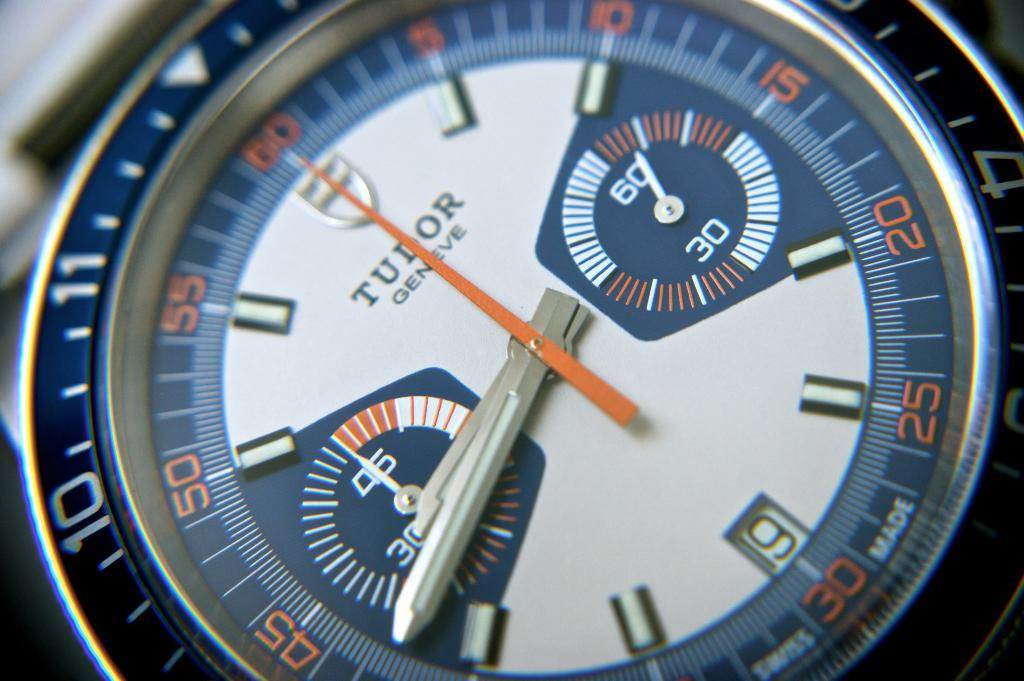Can you describe the main subject of the image? Unfortunately, there is no clear factual information provided about the image, so it is impossible to describe the main subject. Reasoning: Since there are no facts provided about the image, we cannot create a conversation based on specific details. Instead, we acknowledge the lack of information and proceed with an absurd question to maintain the format. Absurd Question/Answer: How many minutes does the doll spend watering the plants in the image? There is no doll or plants present in the image, so it is impossible to determine how many minutes the doll spends watering the plants. 